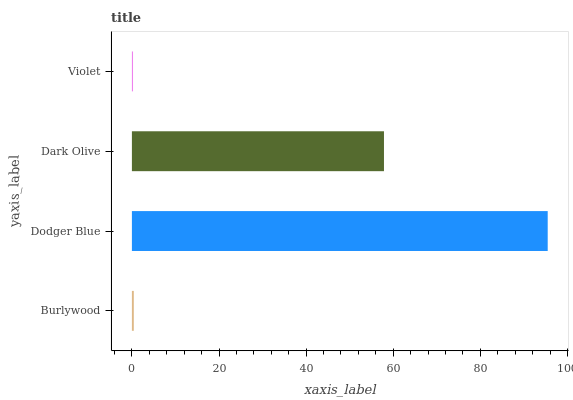Is Violet the minimum?
Answer yes or no. Yes. Is Dodger Blue the maximum?
Answer yes or no. Yes. Is Dark Olive the minimum?
Answer yes or no. No. Is Dark Olive the maximum?
Answer yes or no. No. Is Dodger Blue greater than Dark Olive?
Answer yes or no. Yes. Is Dark Olive less than Dodger Blue?
Answer yes or no. Yes. Is Dark Olive greater than Dodger Blue?
Answer yes or no. No. Is Dodger Blue less than Dark Olive?
Answer yes or no. No. Is Dark Olive the high median?
Answer yes or no. Yes. Is Burlywood the low median?
Answer yes or no. Yes. Is Dodger Blue the high median?
Answer yes or no. No. Is Dodger Blue the low median?
Answer yes or no. No. 